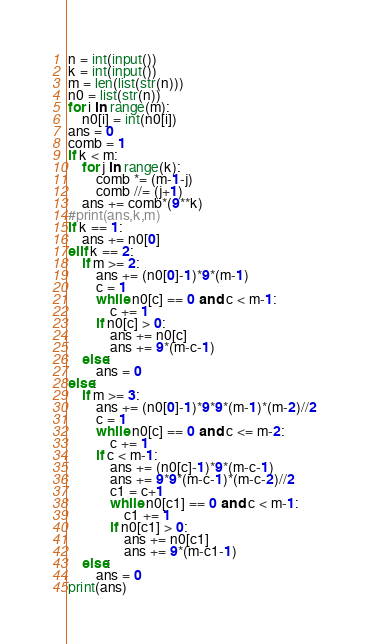Convert code to text. <code><loc_0><loc_0><loc_500><loc_500><_Python_>n = int(input())
k = int(input())
m = len(list(str(n)))
n0 = list(str(n))
for i in range(m):
    n0[i] = int(n0[i])
ans = 0
comb = 1
if k < m:
    for j in range(k):
        comb *= (m-1-j)
        comb //= (j+1)
    ans += comb*(9**k)
#print(ans,k,m)
if k == 1:
    ans += n0[0]
elif k == 2:
    if m >= 2:
        ans += (n0[0]-1)*9*(m-1)
        c = 1
        while n0[c] == 0 and c < m-1:
            c += 1
        if n0[c] > 0:
            ans += n0[c]
            ans += 9*(m-c-1)
    else:
        ans = 0
else:
    if m >= 3:
        ans += (n0[0]-1)*9*9*(m-1)*(m-2)//2
        c = 1
        while n0[c] == 0 and c <= m-2:
            c += 1
        if c < m-1:
            ans += (n0[c]-1)*9*(m-c-1)
            ans += 9*9*(m-c-1)*(m-c-2)//2
            c1 = c+1
            while n0[c1] == 0 and c < m-1:
                c1 += 1
            if n0[c1] > 0:
                ans += n0[c1]
                ans += 9*(m-c1-1)
    else:
        ans = 0
print(ans)</code> 